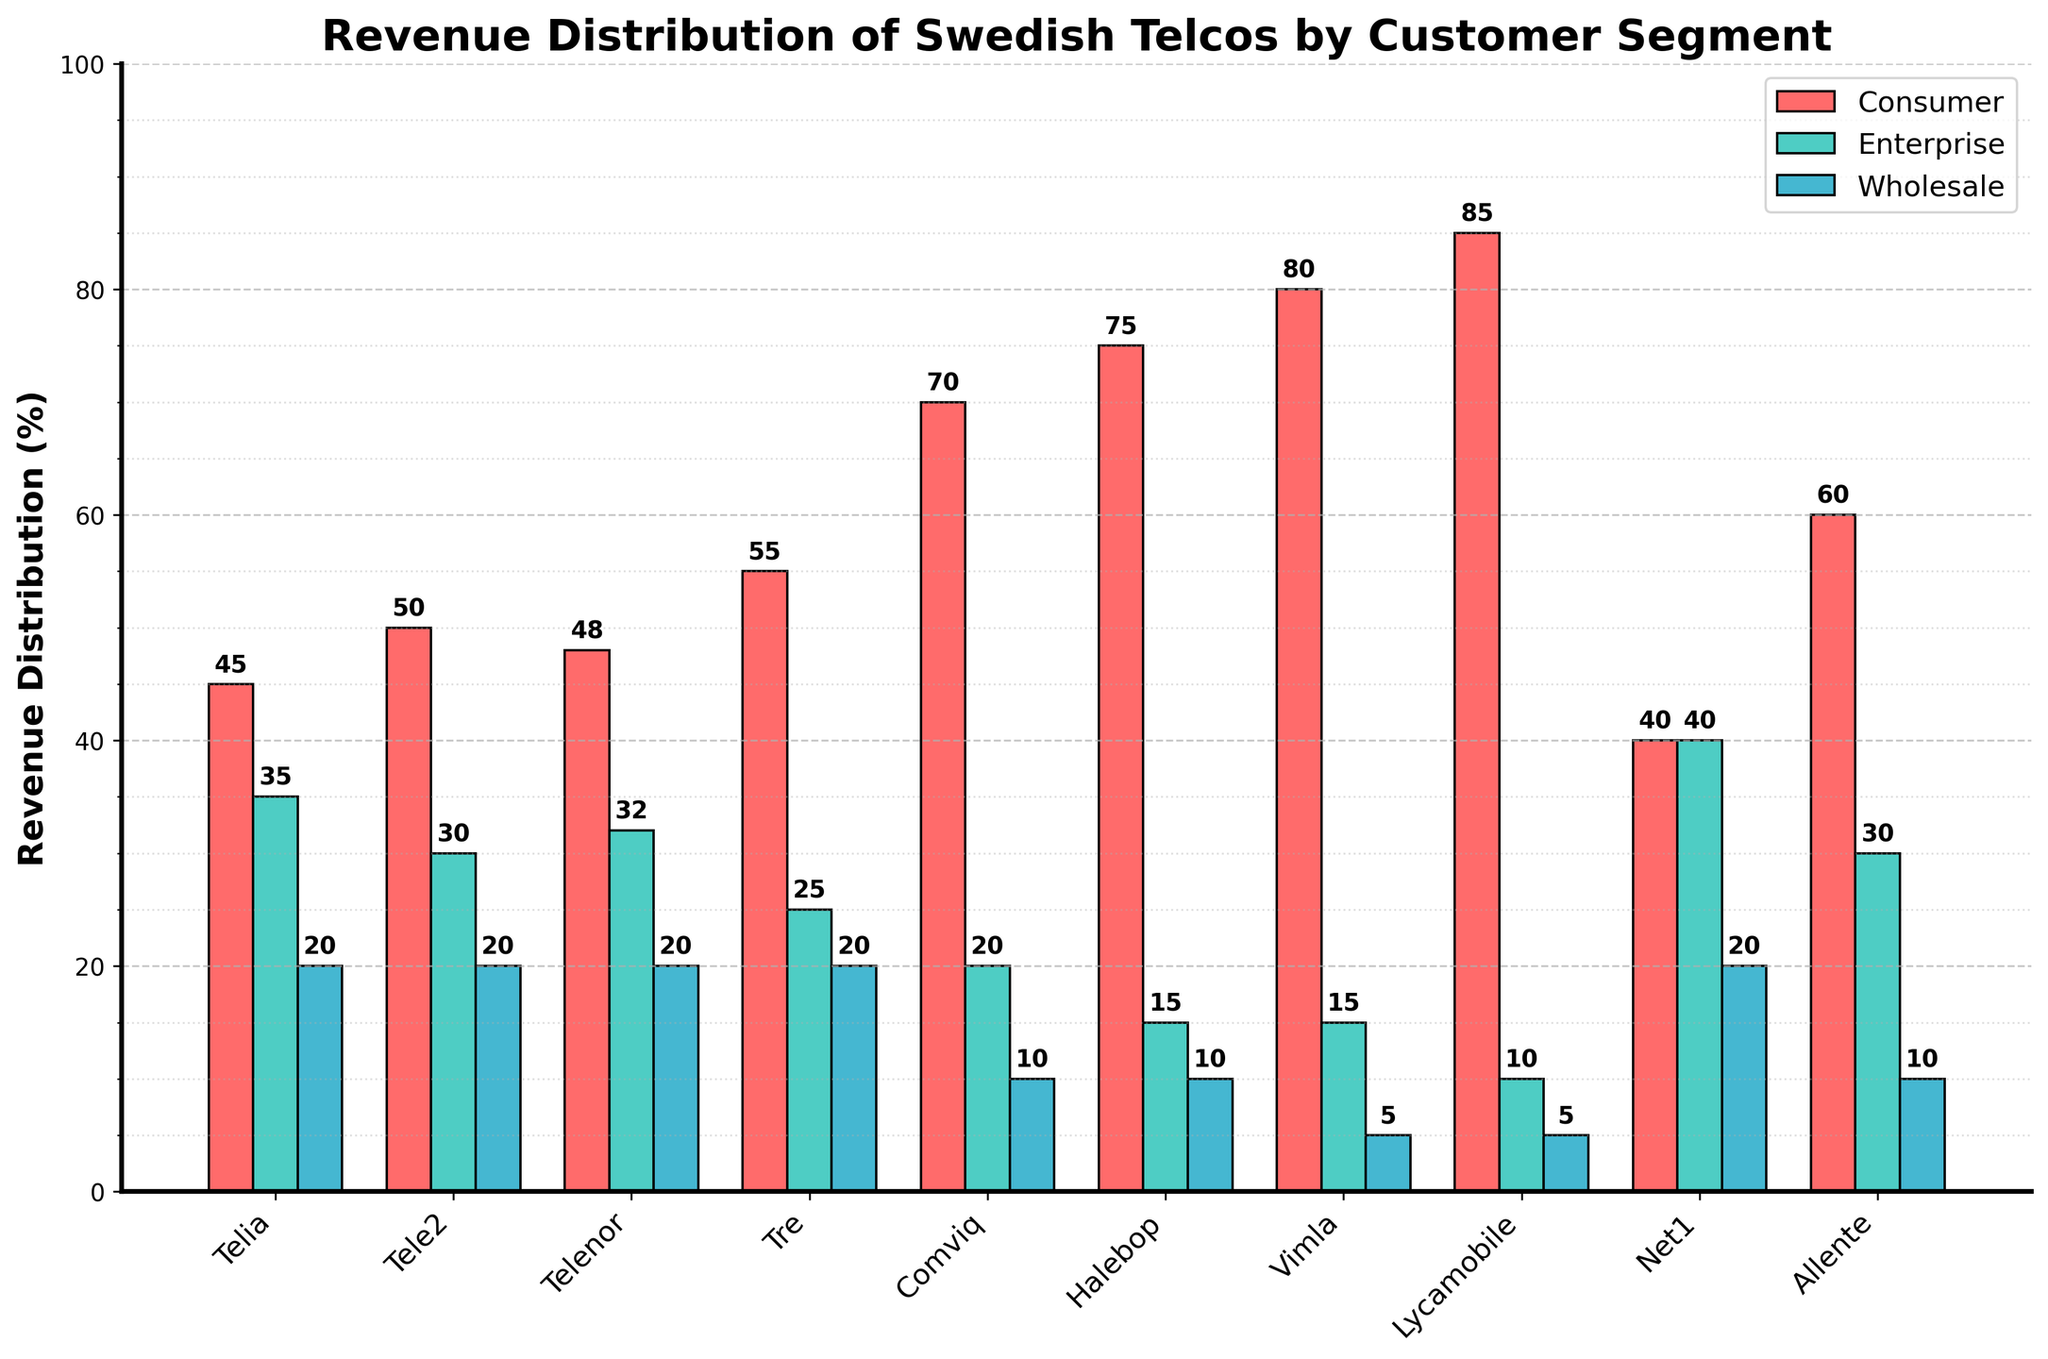What is the sum of the Consumer and Enterprise revenue distribution for Tele2? To find the sum, add the Consumer revenue percentage (50) and the Enterprise revenue percentage (30) for Tele2.
Answer: 80 Which telco has the highest Consumer revenue distribution? Look at the heights of the bars labeled 'Consumer' and identify the one that reaches the highest point on the y-axis. Vimla has the highest Consumer revenue distribution at 80%.
Answer: Vimla How does the Enterprise revenue distribution of Lycamobile compare to that of Halebop? Compare the heights of the bars labeled 'Enterprise' for Lycamobile and Halebop. Lycamobile has 10% and Halebop has 15%, so Halebop is higher.
Answer: Halebop is higher What is the difference between the Wholesale revenue distributions of Telenor and Tre? Subtract the Wholesale revenue percentage of Telenor (20) from that of Tre (20).
Answer: 0 Which telco has the largest gap between Consumer and Enterprise revenue distribution? Calculate the difference between Consumer and Enterprise revenue distributions for each telco. Halebop has a difference of 75 - 15 = 60, which is the largest gap.
Answer: Halebop What is the average Consumer revenue distribution across all telcos? Sum the Consumer revenue percentages of all telcos (45 + 50 + 48 + 55 + 70 + 75 + 80 + 85 + 40 + 60) and divide by the number of telcos (10). The sum is 608, so the average is 608 / 10 = 60.8.
Answer: 60.8 Is there any telco whose Enterprise and Wholesale revenues are equal? Check the bar heights for Enterprise and Wholesale revenues for each telco to identify if any are equal. Net1 has both Enterprise and Wholesale revenues at 40 and 20, respectively.
Answer: Net1 Which telco has the smallest Wholesale revenue distribution? Look at the heights of the bars labeled 'Wholesale' and identify the smallest one. Vimla and Lycamobile both have the smallest Wholesale revenue distribution at 5%.
Answer: Vimla and Lycamobile What is the combined revenue distribution for Consumer and Wholesale for Tre? Add the Consumer revenue percentage (55) and the Wholesale revenue percentage (20) for Tre.
Answer: 75 How many telcos have a Consumer revenue distribution greater than 50%? Count the number of bars labeled 'Consumer' that extend above the 50% mark on the y-axis. Telcos with Consumer revenue greater than 50% are Comviq, Halebop, Vimla, and Lycamobile, which total 4.
Answer: 4 